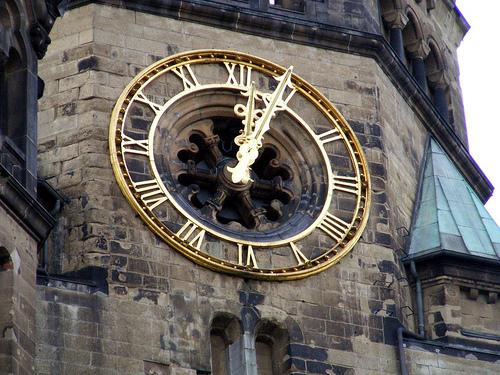What time is the clock saying it is?
Be succinct. 12:04. What time is it on the clock?
Keep it brief. 12:04. What color is the clock?
Quick response, please. Gold. Is this a historical tower?
Be succinct. Yes. Does the clock have a second hand?
Answer briefly. Yes. Is that the right time?
Write a very short answer. Yes. What time does the clock say?
Give a very brief answer. 12:05. What time is it?
Keep it brief. 12:05. What color are the handles of the clock?
Give a very brief answer. Gold. 